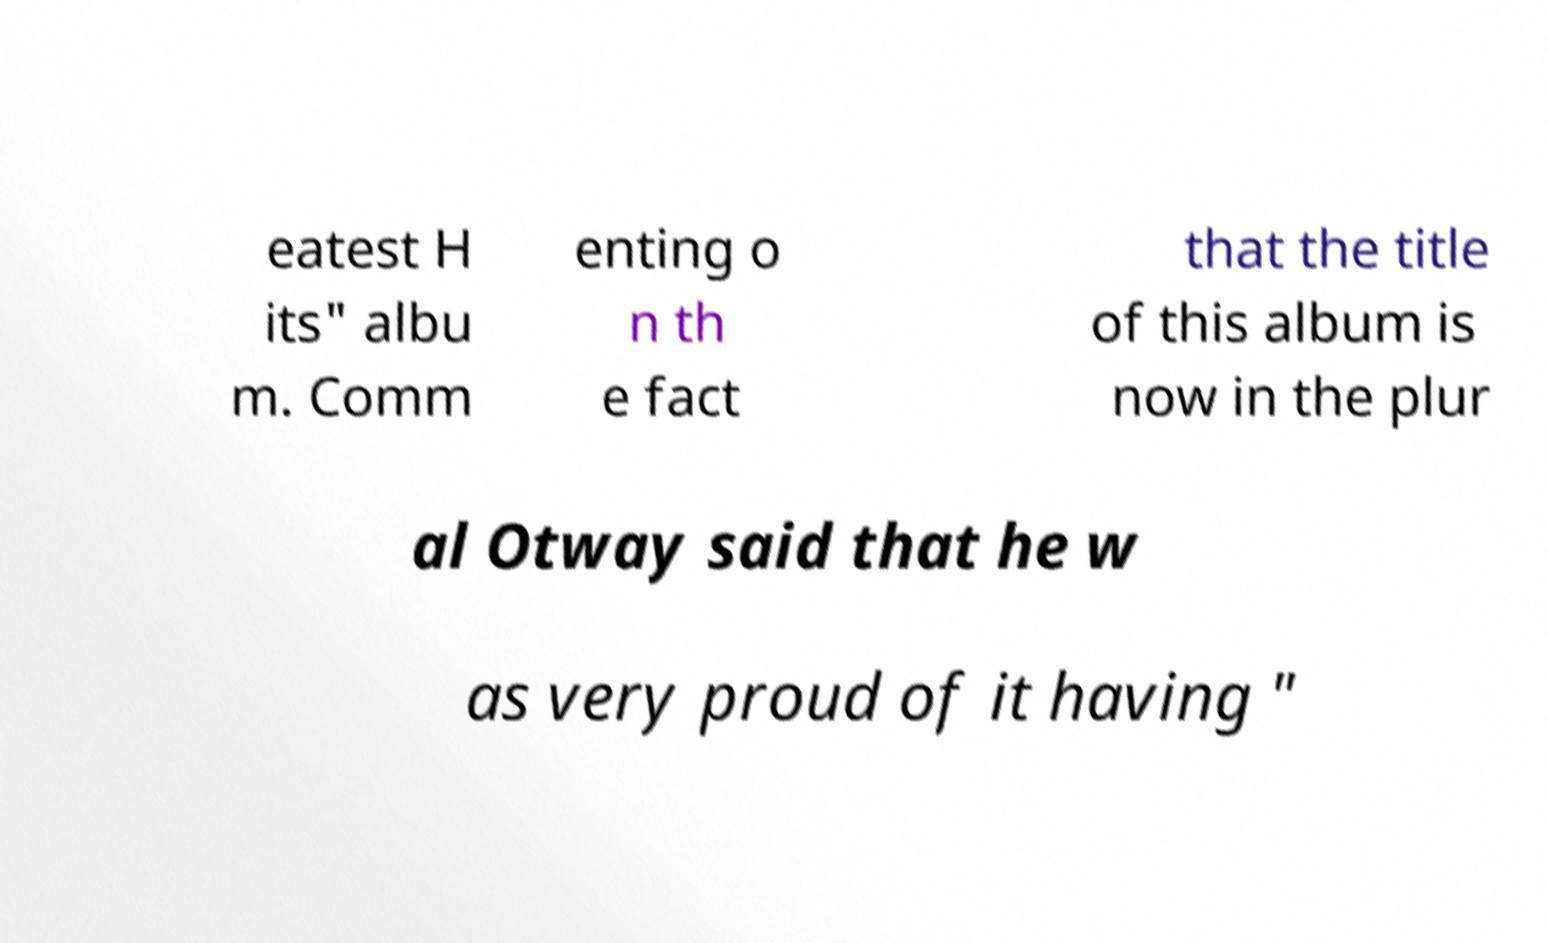Could you assist in decoding the text presented in this image and type it out clearly? eatest H its" albu m. Comm enting o n th e fact that the title of this album is now in the plur al Otway said that he w as very proud of it having " 